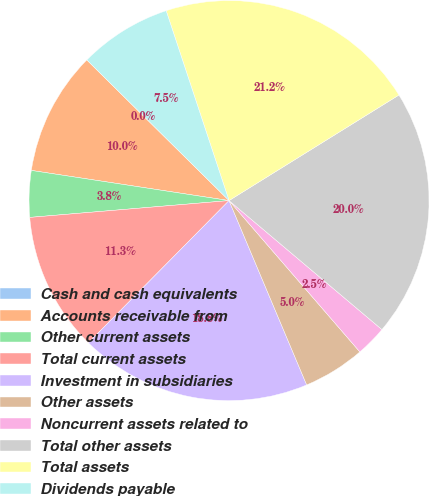Convert chart. <chart><loc_0><loc_0><loc_500><loc_500><pie_chart><fcel>Cash and cash equivalents<fcel>Accounts receivable from<fcel>Other current assets<fcel>Total current assets<fcel>Investment in subsidiaries<fcel>Other assets<fcel>Noncurrent assets related to<fcel>Total other assets<fcel>Total assets<fcel>Dividends payable<nl><fcel>0.0%<fcel>10.0%<fcel>3.75%<fcel>11.25%<fcel>18.75%<fcel>5.0%<fcel>2.5%<fcel>20.0%<fcel>21.24%<fcel>7.5%<nl></chart> 